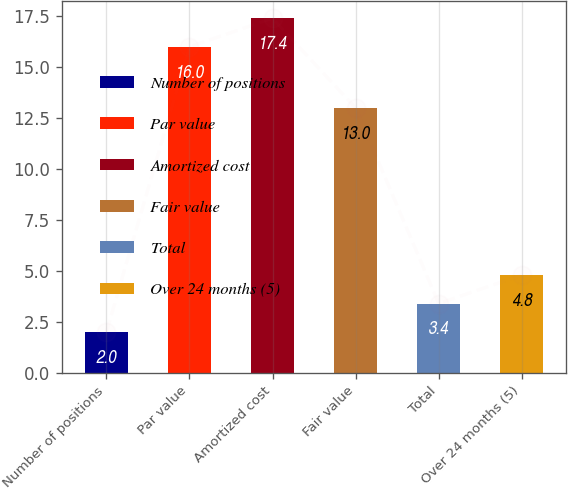Convert chart. <chart><loc_0><loc_0><loc_500><loc_500><bar_chart><fcel>Number of positions<fcel>Par value<fcel>Amortized cost<fcel>Fair value<fcel>Total<fcel>Over 24 months (5)<nl><fcel>2<fcel>16<fcel>17.4<fcel>13<fcel>3.4<fcel>4.8<nl></chart> 